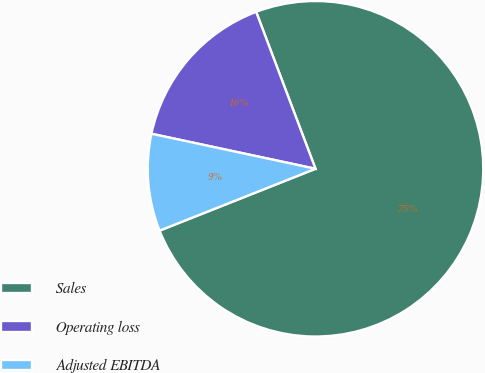Convert chart to OTSL. <chart><loc_0><loc_0><loc_500><loc_500><pie_chart><fcel>Sales<fcel>Operating loss<fcel>Adjusted EBITDA<nl><fcel>74.75%<fcel>15.9%<fcel>9.36%<nl></chart> 